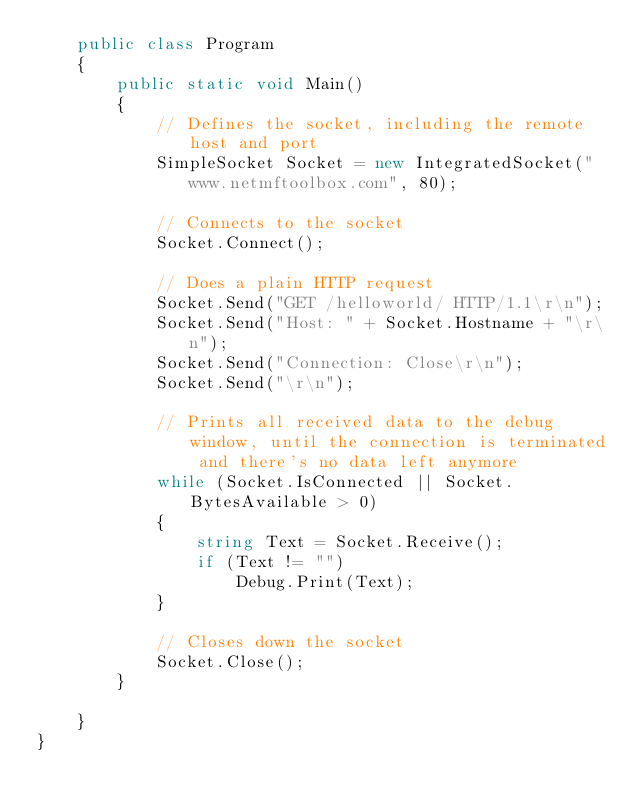Convert code to text. <code><loc_0><loc_0><loc_500><loc_500><_C#_>    public class Program
    {
        public static void Main()
        {
            // Defines the socket, including the remote host and port
            SimpleSocket Socket = new IntegratedSocket("www.netmftoolbox.com", 80);

            // Connects to the socket
            Socket.Connect();

            // Does a plain HTTP request
            Socket.Send("GET /helloworld/ HTTP/1.1\r\n");
            Socket.Send("Host: " + Socket.Hostname + "\r\n");
            Socket.Send("Connection: Close\r\n");
            Socket.Send("\r\n");

            // Prints all received data to the debug window, until the connection is terminated and there's no data left anymore
            while (Socket.IsConnected || Socket.BytesAvailable > 0)
            {
                string Text = Socket.Receive();
                if (Text != "")
                    Debug.Print(Text);
            }

            // Closes down the socket
            Socket.Close();
        }

    }
}
</code> 